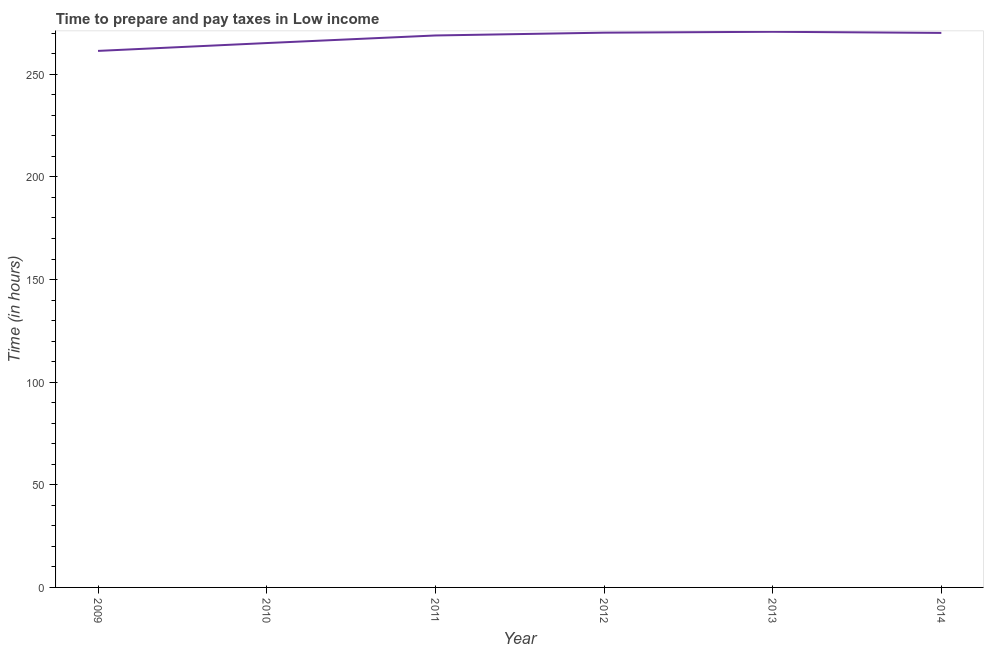What is the time to prepare and pay taxes in 2009?
Your response must be concise. 261.39. Across all years, what is the maximum time to prepare and pay taxes?
Offer a terse response. 270.71. Across all years, what is the minimum time to prepare and pay taxes?
Keep it short and to the point. 261.39. In which year was the time to prepare and pay taxes minimum?
Make the answer very short. 2009. What is the sum of the time to prepare and pay taxes?
Offer a very short reply. 1606.66. What is the difference between the time to prepare and pay taxes in 2010 and 2012?
Offer a very short reply. -5.06. What is the average time to prepare and pay taxes per year?
Keep it short and to the point. 267.78. What is the median time to prepare and pay taxes?
Provide a short and direct response. 269.53. What is the ratio of the time to prepare and pay taxes in 2012 to that in 2014?
Your response must be concise. 1. Is the time to prepare and pay taxes in 2013 less than that in 2014?
Ensure brevity in your answer.  No. What is the difference between the highest and the second highest time to prepare and pay taxes?
Keep it short and to the point. 0.43. What is the difference between the highest and the lowest time to prepare and pay taxes?
Your response must be concise. 9.31. In how many years, is the time to prepare and pay taxes greater than the average time to prepare and pay taxes taken over all years?
Your answer should be compact. 4. How many lines are there?
Keep it short and to the point. 1. Does the graph contain any zero values?
Provide a short and direct response. No. Does the graph contain grids?
Keep it short and to the point. No. What is the title of the graph?
Offer a very short reply. Time to prepare and pay taxes in Low income. What is the label or title of the Y-axis?
Keep it short and to the point. Time (in hours). What is the Time (in hours) in 2009?
Provide a succinct answer. 261.39. What is the Time (in hours) in 2010?
Your answer should be very brief. 265.21. What is the Time (in hours) in 2011?
Give a very brief answer. 268.91. What is the Time (in hours) in 2012?
Give a very brief answer. 270.28. What is the Time (in hours) in 2013?
Ensure brevity in your answer.  270.71. What is the Time (in hours) in 2014?
Offer a terse response. 270.16. What is the difference between the Time (in hours) in 2009 and 2010?
Provide a short and direct response. -3.82. What is the difference between the Time (in hours) in 2009 and 2011?
Provide a short and direct response. -7.52. What is the difference between the Time (in hours) in 2009 and 2012?
Your response must be concise. -8.88. What is the difference between the Time (in hours) in 2009 and 2013?
Your response must be concise. -9.31. What is the difference between the Time (in hours) in 2009 and 2014?
Offer a very short reply. -8.76. What is the difference between the Time (in hours) in 2010 and 2011?
Offer a very short reply. -3.7. What is the difference between the Time (in hours) in 2010 and 2012?
Offer a terse response. -5.06. What is the difference between the Time (in hours) in 2010 and 2013?
Offer a very short reply. -5.49. What is the difference between the Time (in hours) in 2010 and 2014?
Your response must be concise. -4.94. What is the difference between the Time (in hours) in 2011 and 2012?
Your response must be concise. -1.37. What is the difference between the Time (in hours) in 2011 and 2013?
Keep it short and to the point. -1.8. What is the difference between the Time (in hours) in 2011 and 2014?
Provide a succinct answer. -1.24. What is the difference between the Time (in hours) in 2012 and 2013?
Ensure brevity in your answer.  -0.43. What is the difference between the Time (in hours) in 2012 and 2014?
Provide a succinct answer. 0.12. What is the difference between the Time (in hours) in 2013 and 2014?
Offer a terse response. 0.55. What is the ratio of the Time (in hours) in 2009 to that in 2011?
Provide a short and direct response. 0.97. What is the ratio of the Time (in hours) in 2009 to that in 2012?
Keep it short and to the point. 0.97. What is the ratio of the Time (in hours) in 2009 to that in 2014?
Your response must be concise. 0.97. What is the ratio of the Time (in hours) in 2010 to that in 2011?
Your answer should be compact. 0.99. What is the ratio of the Time (in hours) in 2010 to that in 2012?
Your answer should be very brief. 0.98. What is the ratio of the Time (in hours) in 2012 to that in 2013?
Make the answer very short. 1. What is the ratio of the Time (in hours) in 2012 to that in 2014?
Offer a very short reply. 1. What is the ratio of the Time (in hours) in 2013 to that in 2014?
Your answer should be very brief. 1. 